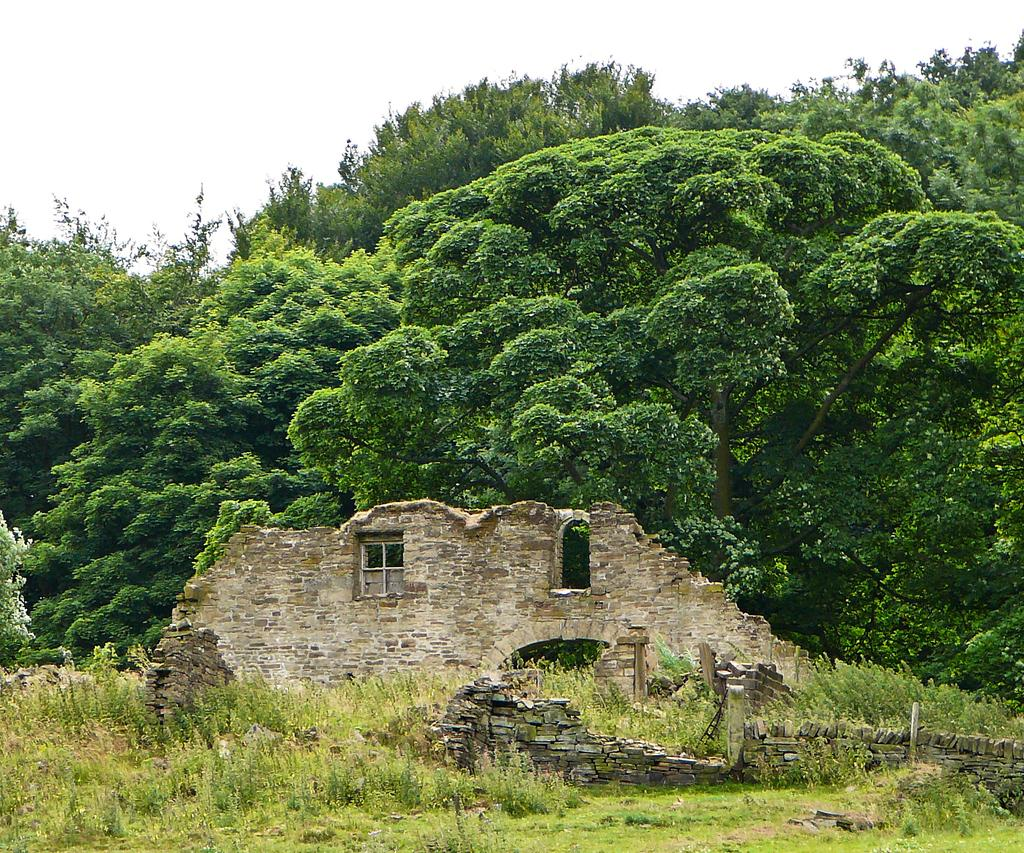What is the main feature of the wall in the image? There are two windows in the wall in the image. What is located near the wall in the image? There is a small wall with rocks in the image. What type of natural elements can be seen on the surface in the image? There are stones on the surface in the image. What type of vegetation is present in the image? There are big trees, plants, bushes, and grass in the image. What is visible at the top of the image? The sky is visible at the top of the image. Where can the calculator be found in the image? There is no calculator present in the image. What type of rose is growing near the big trees in the image? There are no roses present in the image; only trees, plants, bushes, and grass can be seen. 